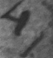Please transcribe the handwritten text in this image. 4 ) 